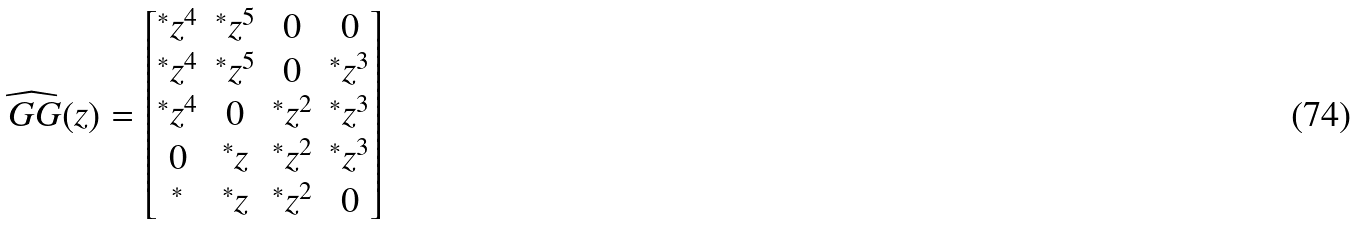Convert formula to latex. <formula><loc_0><loc_0><loc_500><loc_500>\widehat { \ G G } ( z ) = \begin{bmatrix} ^ { * } z ^ { 4 } & ^ { * } z ^ { 5 } & 0 & 0 \\ ^ { * } z ^ { 4 } & ^ { * } z ^ { 5 } & 0 & ^ { * } z ^ { 3 } \\ ^ { * } z ^ { 4 } & 0 & ^ { * } z ^ { 2 } & ^ { * } z ^ { 3 } \\ 0 & ^ { * } z & ^ { * } z ^ { 2 } & ^ { * } z ^ { 3 } \\ ^ { * } & ^ { * } z & ^ { * } z ^ { 2 } & 0 \\ \end{bmatrix}</formula> 